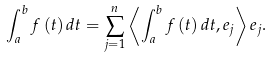<formula> <loc_0><loc_0><loc_500><loc_500>\int _ { a } ^ { b } f \left ( t \right ) d t = \sum _ { j = 1 } ^ { n } \left \langle \int _ { a } ^ { b } f \left ( t \right ) d t , e _ { j } \right \rangle e _ { j } .</formula> 